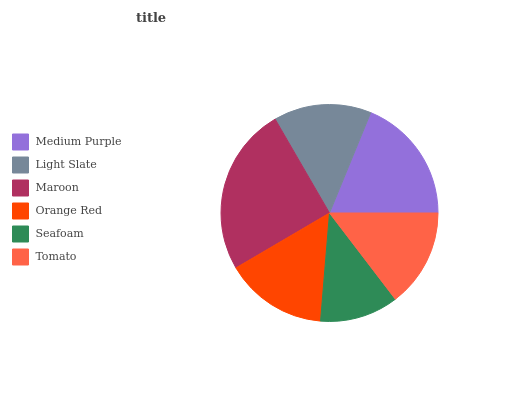Is Seafoam the minimum?
Answer yes or no. Yes. Is Maroon the maximum?
Answer yes or no. Yes. Is Light Slate the minimum?
Answer yes or no. No. Is Light Slate the maximum?
Answer yes or no. No. Is Medium Purple greater than Light Slate?
Answer yes or no. Yes. Is Light Slate less than Medium Purple?
Answer yes or no. Yes. Is Light Slate greater than Medium Purple?
Answer yes or no. No. Is Medium Purple less than Light Slate?
Answer yes or no. No. Is Orange Red the high median?
Answer yes or no. Yes. Is Tomato the low median?
Answer yes or no. Yes. Is Light Slate the high median?
Answer yes or no. No. Is Light Slate the low median?
Answer yes or no. No. 